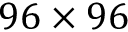<formula> <loc_0><loc_0><loc_500><loc_500>9 6 \times 9 6</formula> 